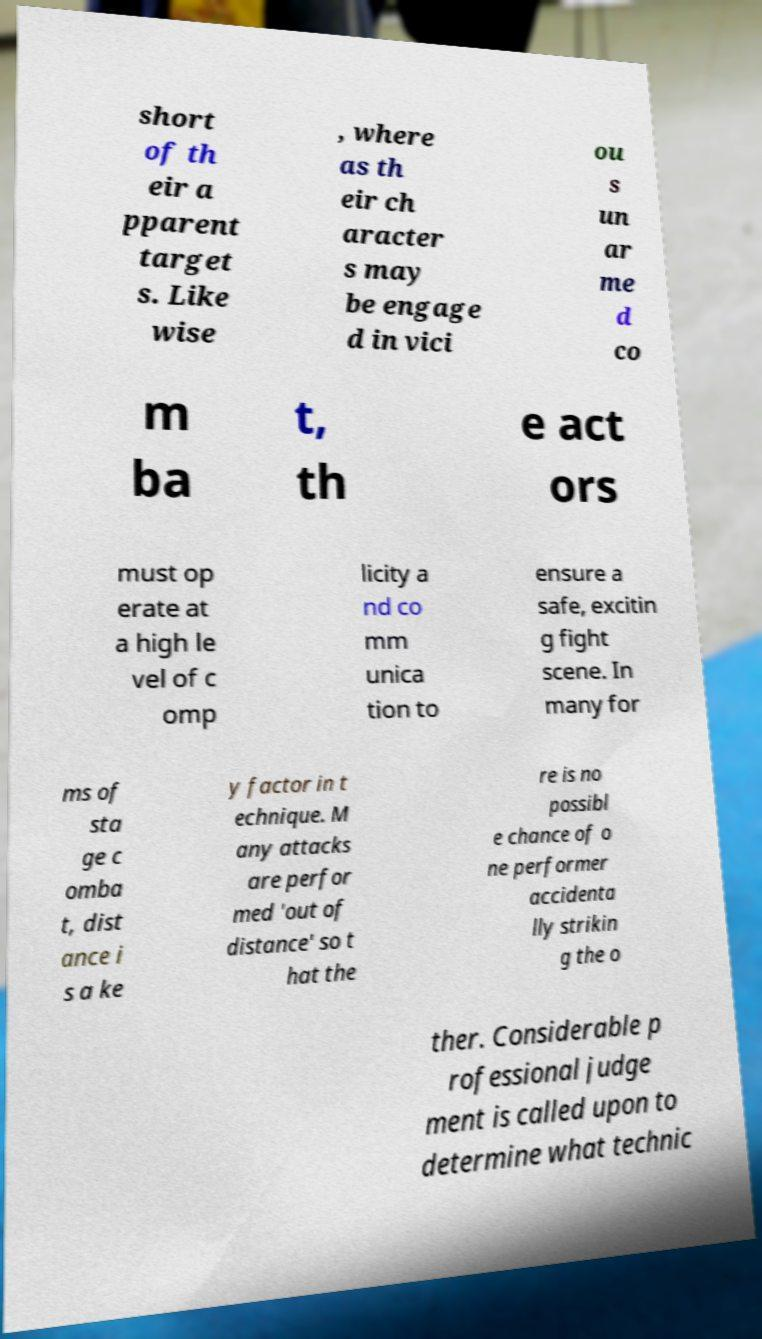What messages or text are displayed in this image? I need them in a readable, typed format. short of th eir a pparent target s. Like wise , where as th eir ch aracter s may be engage d in vici ou s un ar me d co m ba t, th e act ors must op erate at a high le vel of c omp licity a nd co mm unica tion to ensure a safe, excitin g fight scene. In many for ms of sta ge c omba t, dist ance i s a ke y factor in t echnique. M any attacks are perfor med 'out of distance' so t hat the re is no possibl e chance of o ne performer accidenta lly strikin g the o ther. Considerable p rofessional judge ment is called upon to determine what technic 